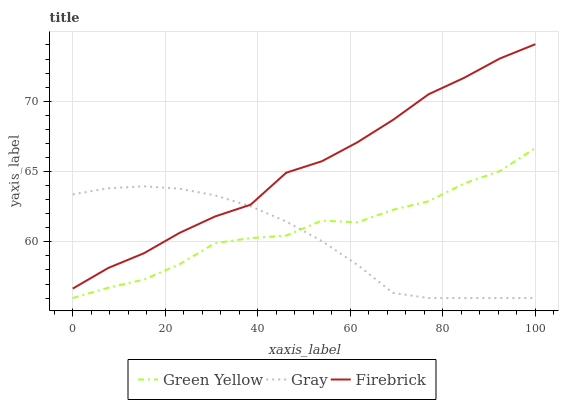Does Gray have the minimum area under the curve?
Answer yes or no. Yes. Does Firebrick have the maximum area under the curve?
Answer yes or no. Yes. Does Green Yellow have the minimum area under the curve?
Answer yes or no. No. Does Green Yellow have the maximum area under the curve?
Answer yes or no. No. Is Gray the smoothest?
Answer yes or no. Yes. Is Green Yellow the roughest?
Answer yes or no. Yes. Is Firebrick the smoothest?
Answer yes or no. No. Is Firebrick the roughest?
Answer yes or no. No. Does Gray have the lowest value?
Answer yes or no. Yes. Does Firebrick have the lowest value?
Answer yes or no. No. Does Firebrick have the highest value?
Answer yes or no. Yes. Does Green Yellow have the highest value?
Answer yes or no. No. Is Green Yellow less than Firebrick?
Answer yes or no. Yes. Is Firebrick greater than Green Yellow?
Answer yes or no. Yes. Does Gray intersect Firebrick?
Answer yes or no. Yes. Is Gray less than Firebrick?
Answer yes or no. No. Is Gray greater than Firebrick?
Answer yes or no. No. Does Green Yellow intersect Firebrick?
Answer yes or no. No. 